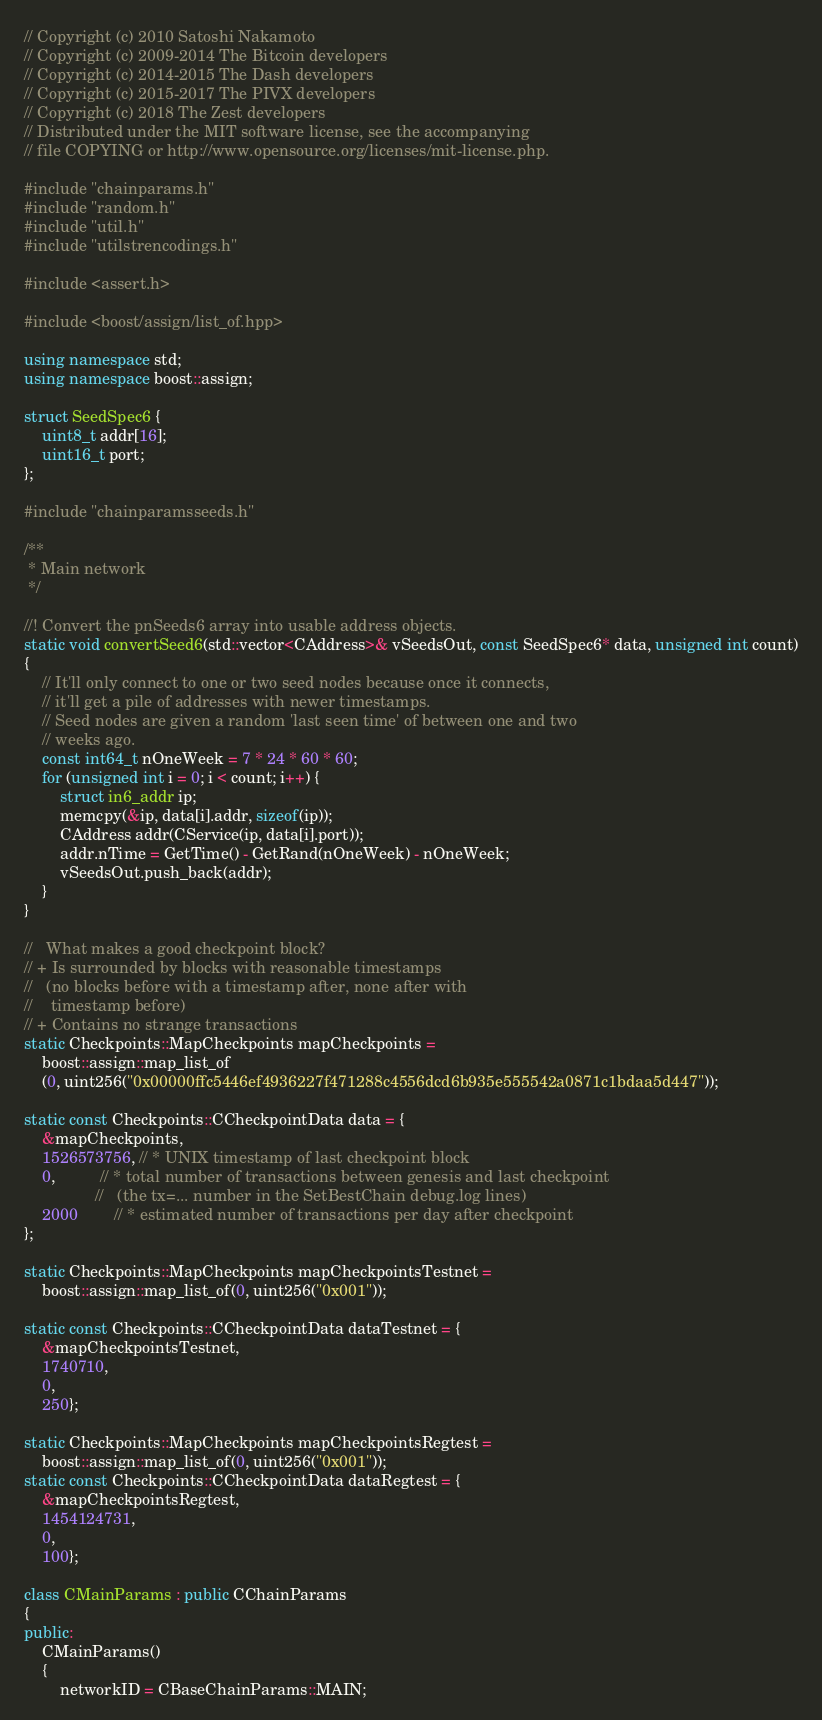Convert code to text. <code><loc_0><loc_0><loc_500><loc_500><_C++_>// Copyright (c) 2010 Satoshi Nakamoto
// Copyright (c) 2009-2014 The Bitcoin developers
// Copyright (c) 2014-2015 The Dash developers
// Copyright (c) 2015-2017 The PIVX developers
// Copyright (c) 2018 The Zest developers
// Distributed under the MIT software license, see the accompanying
// file COPYING or http://www.opensource.org/licenses/mit-license.php.

#include "chainparams.h"
#include "random.h"
#include "util.h"
#include "utilstrencodings.h"

#include <assert.h>

#include <boost/assign/list_of.hpp>

using namespace std;
using namespace boost::assign;

struct SeedSpec6 {
    uint8_t addr[16];
    uint16_t port;
};

#include "chainparamsseeds.h"

/**
 * Main network
 */

//! Convert the pnSeeds6 array into usable address objects.
static void convertSeed6(std::vector<CAddress>& vSeedsOut, const SeedSpec6* data, unsigned int count)
{
    // It'll only connect to one or two seed nodes because once it connects,
    // it'll get a pile of addresses with newer timestamps.
    // Seed nodes are given a random 'last seen time' of between one and two
    // weeks ago.
    const int64_t nOneWeek = 7 * 24 * 60 * 60;
    for (unsigned int i = 0; i < count; i++) {
        struct in6_addr ip;
        memcpy(&ip, data[i].addr, sizeof(ip));
        CAddress addr(CService(ip, data[i].port));
        addr.nTime = GetTime() - GetRand(nOneWeek) - nOneWeek;
        vSeedsOut.push_back(addr);
    }
}

//   What makes a good checkpoint block?
// + Is surrounded by blocks with reasonable timestamps
//   (no blocks before with a timestamp after, none after with
//    timestamp before)
// + Contains no strange transactions
static Checkpoints::MapCheckpoints mapCheckpoints =
    boost::assign::map_list_of
    (0, uint256("0x00000ffc5446ef4936227f471288c4556dcd6b935e555542a0871c1bdaa5d447"));

static const Checkpoints::CCheckpointData data = {
    &mapCheckpoints,
    1526573756, // * UNIX timestamp of last checkpoint block
    0,          // * total number of transactions between genesis and last checkpoint
                //   (the tx=... number in the SetBestChain debug.log lines)
    2000        // * estimated number of transactions per day after checkpoint
};

static Checkpoints::MapCheckpoints mapCheckpointsTestnet =
    boost::assign::map_list_of(0, uint256("0x001"));

static const Checkpoints::CCheckpointData dataTestnet = {
    &mapCheckpointsTestnet,
    1740710,
    0,
    250};

static Checkpoints::MapCheckpoints mapCheckpointsRegtest =
    boost::assign::map_list_of(0, uint256("0x001"));
static const Checkpoints::CCheckpointData dataRegtest = {
    &mapCheckpointsRegtest,
    1454124731,
    0,
    100};

class CMainParams : public CChainParams
{
public:
    CMainParams()
    {
        networkID = CBaseChainParams::MAIN;</code> 